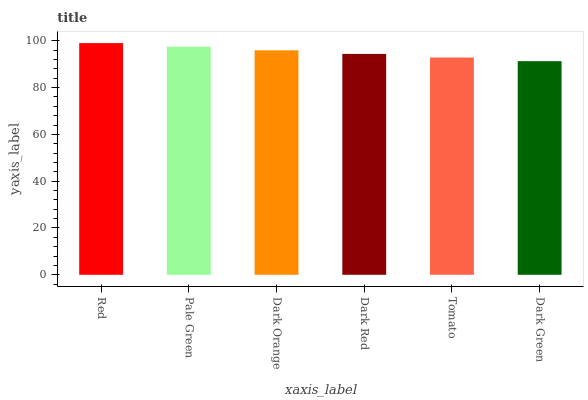Is Dark Green the minimum?
Answer yes or no. Yes. Is Red the maximum?
Answer yes or no. Yes. Is Pale Green the minimum?
Answer yes or no. No. Is Pale Green the maximum?
Answer yes or no. No. Is Red greater than Pale Green?
Answer yes or no. Yes. Is Pale Green less than Red?
Answer yes or no. Yes. Is Pale Green greater than Red?
Answer yes or no. No. Is Red less than Pale Green?
Answer yes or no. No. Is Dark Orange the high median?
Answer yes or no. Yes. Is Dark Red the low median?
Answer yes or no. Yes. Is Pale Green the high median?
Answer yes or no. No. Is Pale Green the low median?
Answer yes or no. No. 